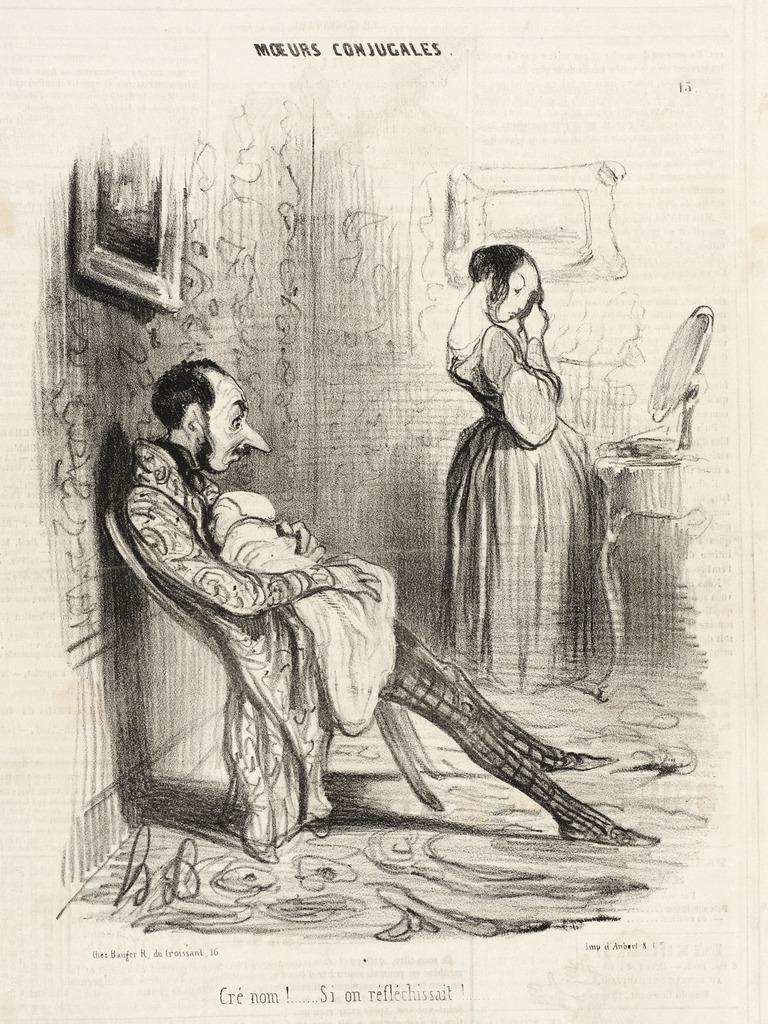Can you describe this image briefly? It is a poster. In this image there is a depiction of a person sitting on the chair by holding the baby. Beside him there is another person standing in front of the mirror. In the background of the image there are photo frames on the wall. There is some text on the image. 